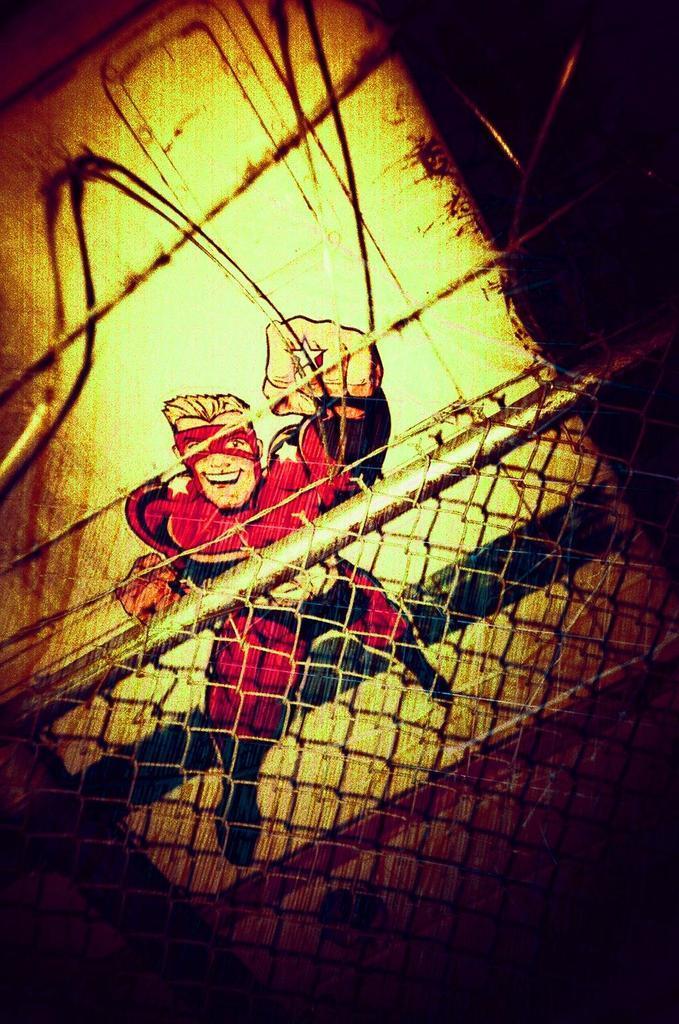Can you describe this image briefly? In this image in the front is a fence and in the background there is a drawing of a cartoon. 